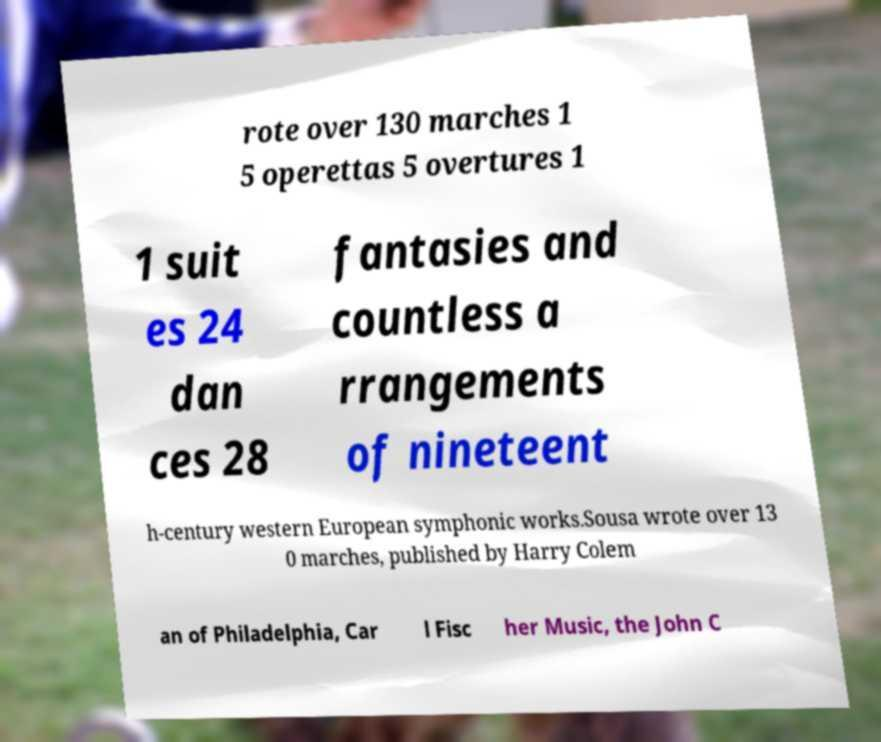Please identify and transcribe the text found in this image. rote over 130 marches 1 5 operettas 5 overtures 1 1 suit es 24 dan ces 28 fantasies and countless a rrangements of nineteent h-century western European symphonic works.Sousa wrote over 13 0 marches, published by Harry Colem an of Philadelphia, Car l Fisc her Music, the John C 